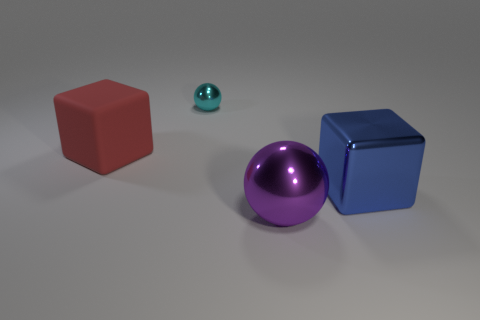Can you tell me what colors are present in the objects pictured? Certainly! The image showcases objects in three distinct colors: a large red cube, a small teal sphere, and both a large purple sphere and a large blue cube. 